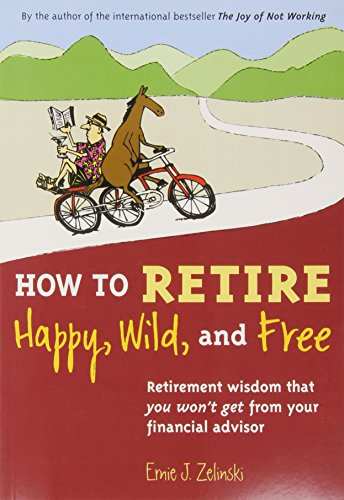What type of book is this? This book is categorized under 'Health, Fitness & Dieting,' focusing primarily on the psychological and lifestyle aspects of retirement, offering advice on how to enjoy a fulfilling and active retirement. 